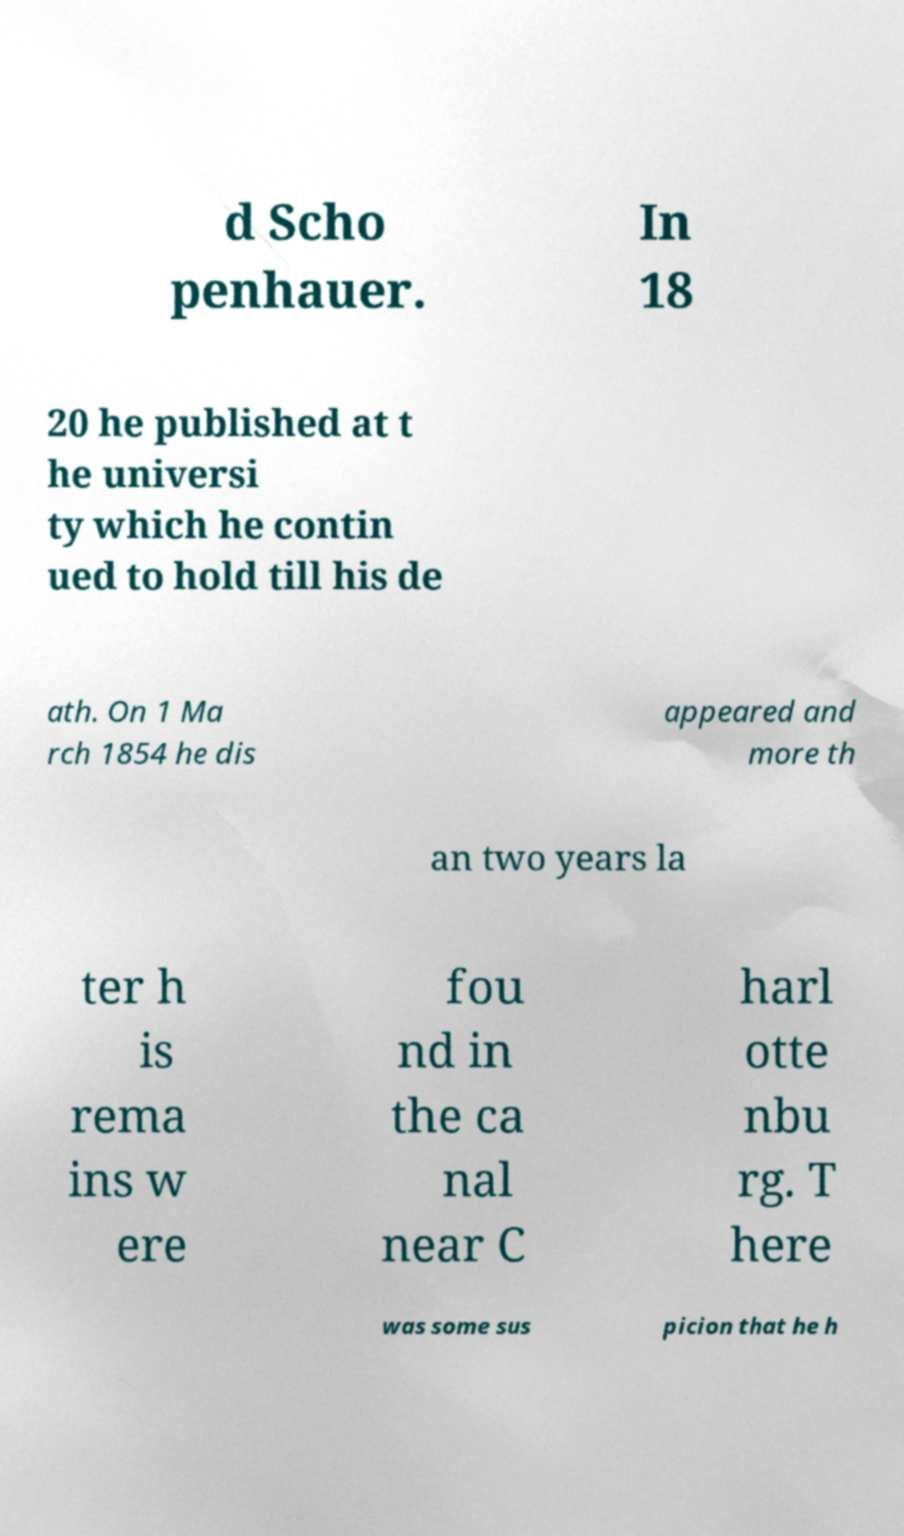Please read and relay the text visible in this image. What does it say? d Scho penhauer. In 18 20 he published at t he universi ty which he contin ued to hold till his de ath. On 1 Ma rch 1854 he dis appeared and more th an two years la ter h is rema ins w ere fou nd in the ca nal near C harl otte nbu rg. T here was some sus picion that he h 